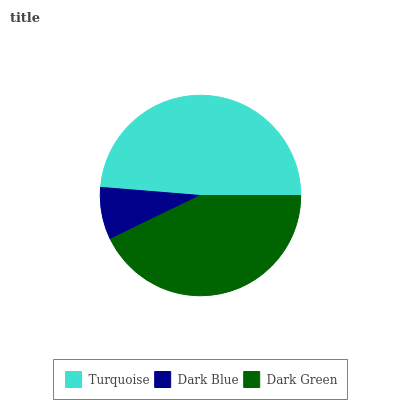Is Dark Blue the minimum?
Answer yes or no. Yes. Is Turquoise the maximum?
Answer yes or no. Yes. Is Dark Green the minimum?
Answer yes or no. No. Is Dark Green the maximum?
Answer yes or no. No. Is Dark Green greater than Dark Blue?
Answer yes or no. Yes. Is Dark Blue less than Dark Green?
Answer yes or no. Yes. Is Dark Blue greater than Dark Green?
Answer yes or no. No. Is Dark Green less than Dark Blue?
Answer yes or no. No. Is Dark Green the high median?
Answer yes or no. Yes. Is Dark Green the low median?
Answer yes or no. Yes. Is Turquoise the high median?
Answer yes or no. No. Is Dark Blue the low median?
Answer yes or no. No. 